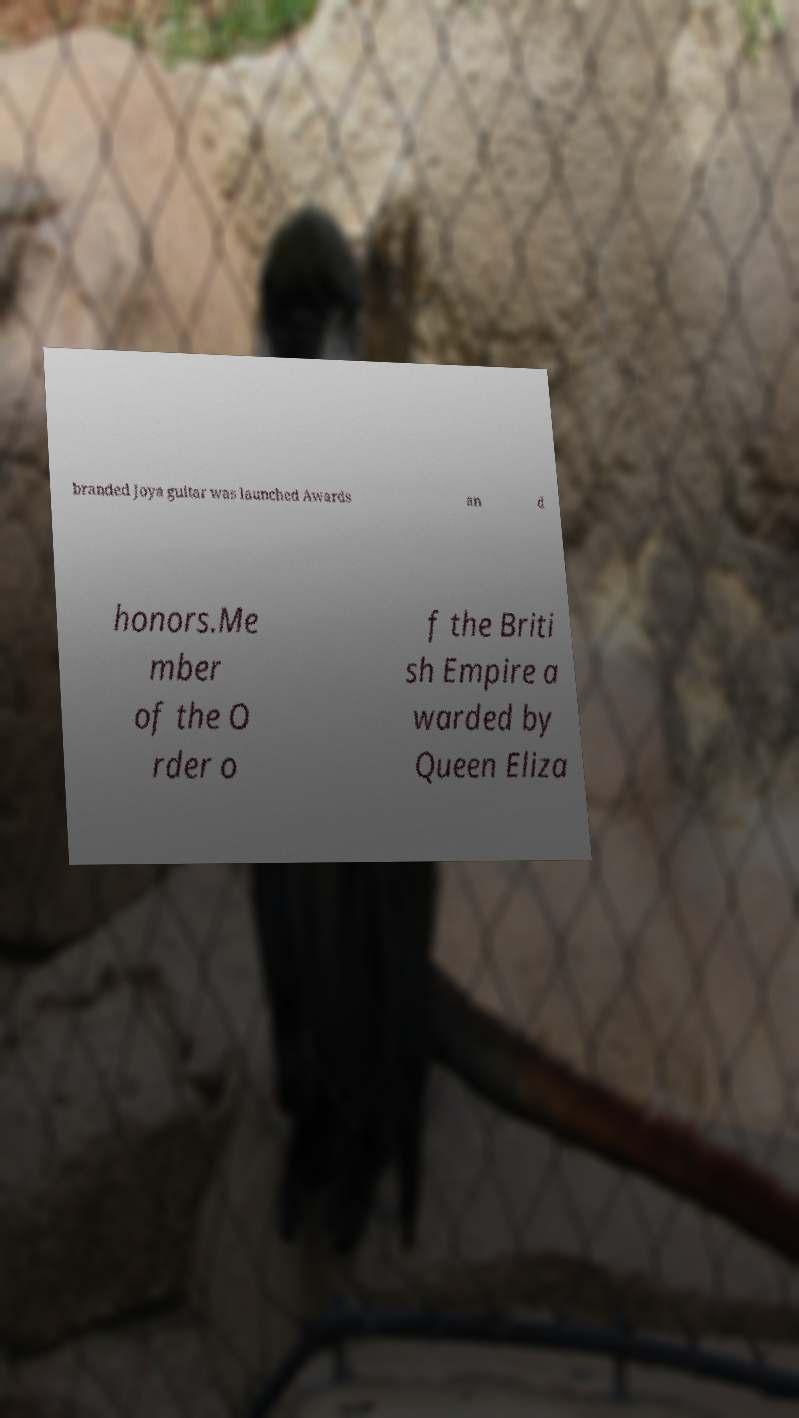Could you extract and type out the text from this image? branded Joya guitar was launched Awards an d honors.Me mber of the O rder o f the Briti sh Empire a warded by Queen Eliza 